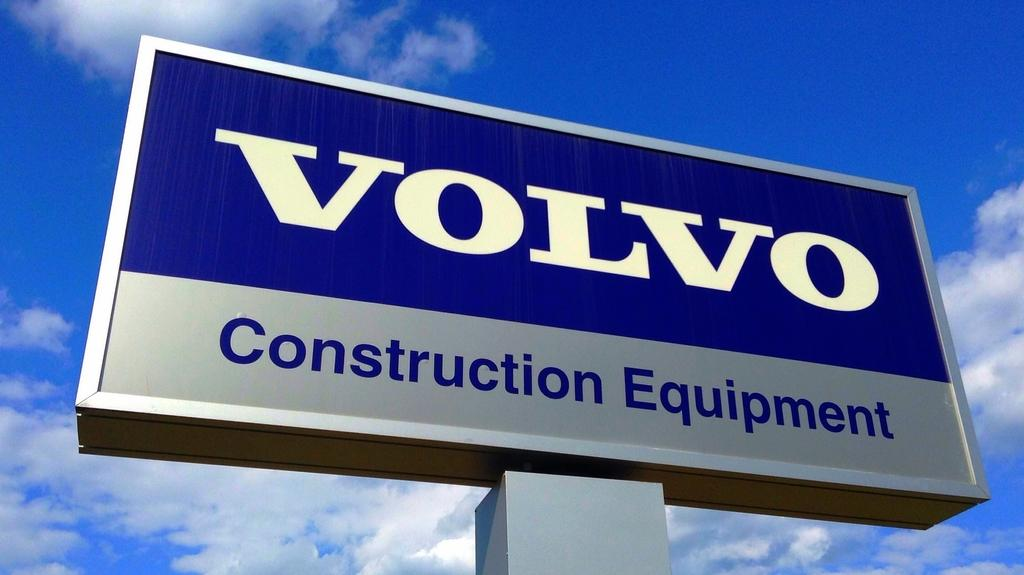<image>
Provide a brief description of the given image. Volvo Construction Equipment with a blue sky behind the sign. 